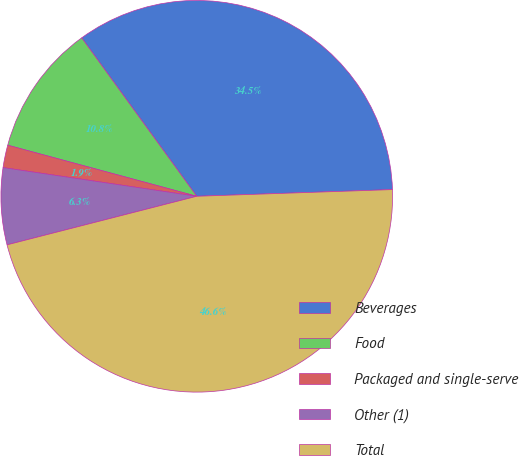Convert chart to OTSL. <chart><loc_0><loc_0><loc_500><loc_500><pie_chart><fcel>Beverages<fcel>Food<fcel>Packaged and single-serve<fcel>Other (1)<fcel>Total<nl><fcel>34.45%<fcel>10.8%<fcel>1.86%<fcel>6.33%<fcel>46.55%<nl></chart> 